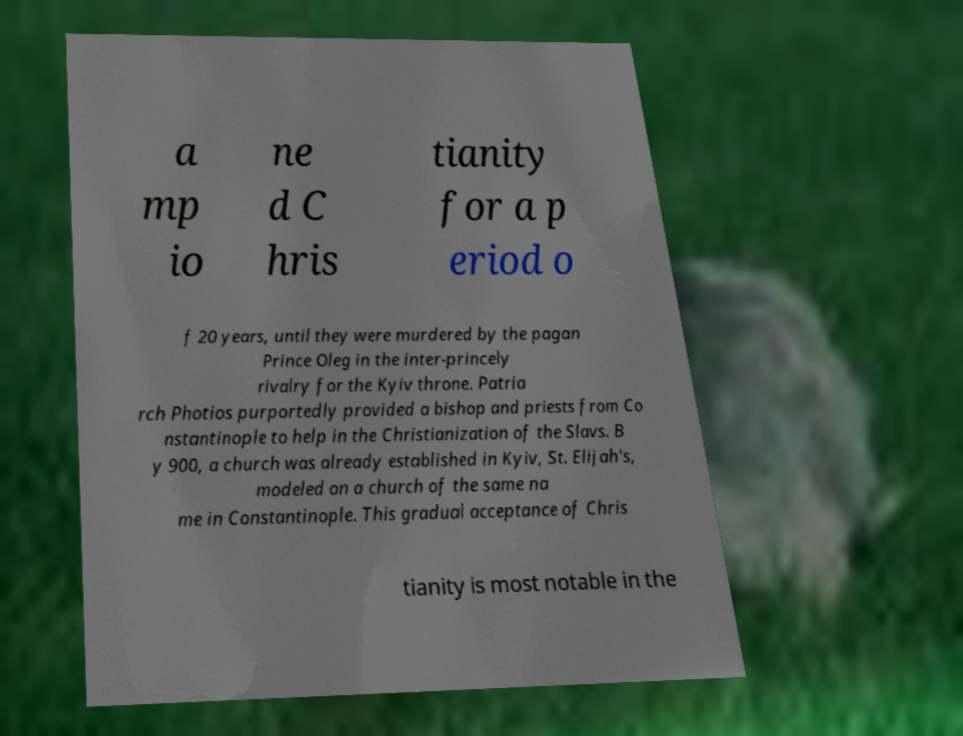Please read and relay the text visible in this image. What does it say? a mp io ne d C hris tianity for a p eriod o f 20 years, until they were murdered by the pagan Prince Oleg in the inter-princely rivalry for the Kyiv throne. Patria rch Photios purportedly provided a bishop and priests from Co nstantinople to help in the Christianization of the Slavs. B y 900, a church was already established in Kyiv, St. Elijah's, modeled on a church of the same na me in Constantinople. This gradual acceptance of Chris tianity is most notable in the 